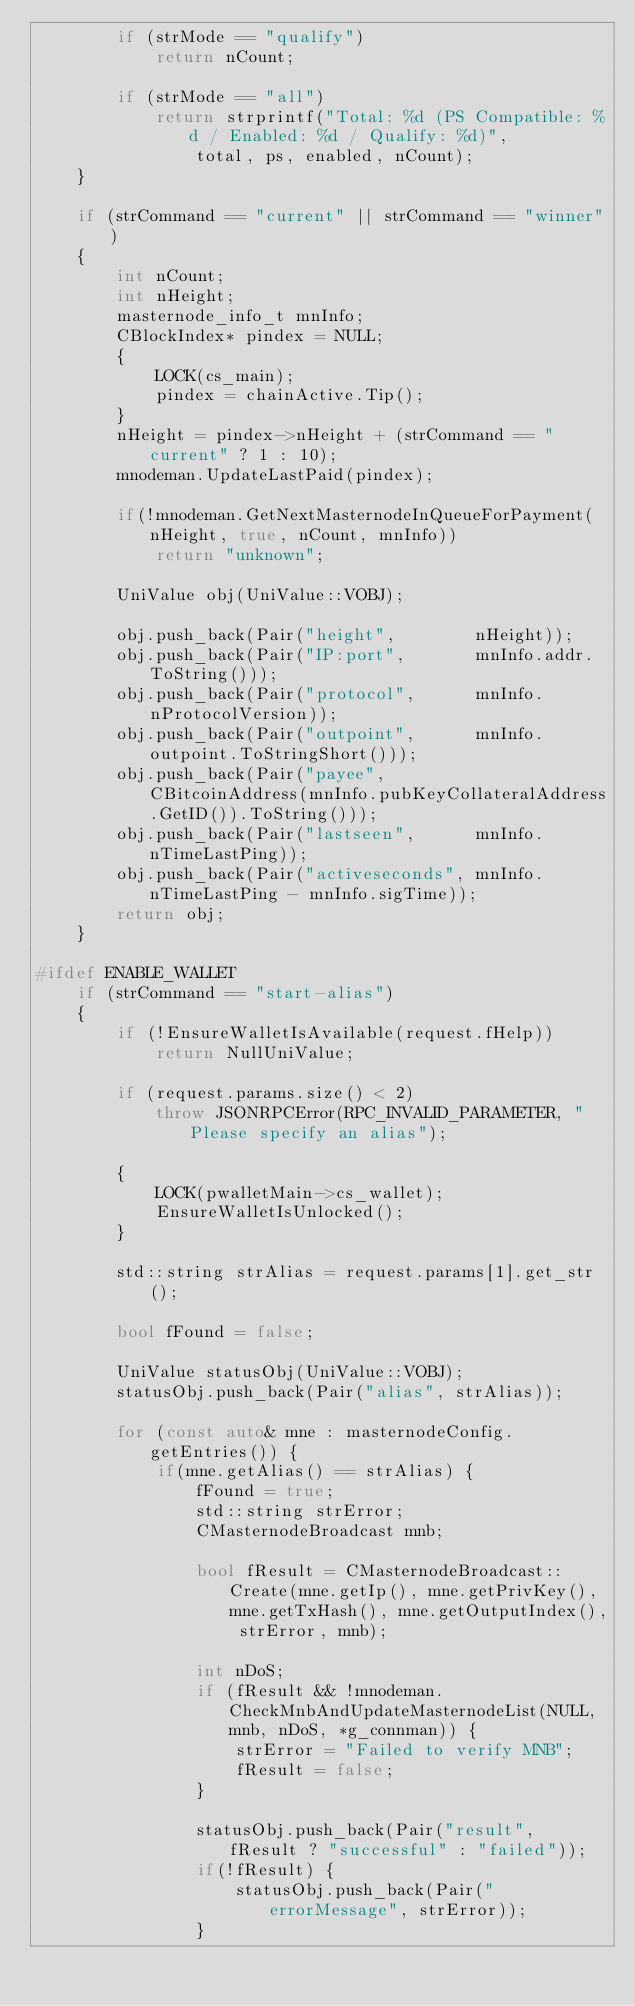<code> <loc_0><loc_0><loc_500><loc_500><_C++_>        if (strMode == "qualify")
            return nCount;

        if (strMode == "all")
            return strprintf("Total: %d (PS Compatible: %d / Enabled: %d / Qualify: %d)",
                total, ps, enabled, nCount);
    }

    if (strCommand == "current" || strCommand == "winner")
    {
        int nCount;
        int nHeight;
        masternode_info_t mnInfo;
        CBlockIndex* pindex = NULL;
        {
            LOCK(cs_main);
            pindex = chainActive.Tip();
        }
        nHeight = pindex->nHeight + (strCommand == "current" ? 1 : 10);
        mnodeman.UpdateLastPaid(pindex);

        if(!mnodeman.GetNextMasternodeInQueueForPayment(nHeight, true, nCount, mnInfo))
            return "unknown";

        UniValue obj(UniValue::VOBJ);

        obj.push_back(Pair("height",        nHeight));
        obj.push_back(Pair("IP:port",       mnInfo.addr.ToString()));
        obj.push_back(Pair("protocol",      mnInfo.nProtocolVersion));
        obj.push_back(Pair("outpoint",      mnInfo.outpoint.ToStringShort()));
        obj.push_back(Pair("payee",         CBitcoinAddress(mnInfo.pubKeyCollateralAddress.GetID()).ToString()));
        obj.push_back(Pair("lastseen",      mnInfo.nTimeLastPing));
        obj.push_back(Pair("activeseconds", mnInfo.nTimeLastPing - mnInfo.sigTime));
        return obj;
    }

#ifdef ENABLE_WALLET
    if (strCommand == "start-alias")
    {
        if (!EnsureWalletIsAvailable(request.fHelp))
            return NullUniValue;

        if (request.params.size() < 2)
            throw JSONRPCError(RPC_INVALID_PARAMETER, "Please specify an alias");

        {
            LOCK(pwalletMain->cs_wallet);
            EnsureWalletIsUnlocked();
        }

        std::string strAlias = request.params[1].get_str();

        bool fFound = false;

        UniValue statusObj(UniValue::VOBJ);
        statusObj.push_back(Pair("alias", strAlias));

        for (const auto& mne : masternodeConfig.getEntries()) {
            if(mne.getAlias() == strAlias) {
                fFound = true;
                std::string strError;
                CMasternodeBroadcast mnb;

                bool fResult = CMasternodeBroadcast::Create(mne.getIp(), mne.getPrivKey(), mne.getTxHash(), mne.getOutputIndex(), strError, mnb);

                int nDoS;
                if (fResult && !mnodeman.CheckMnbAndUpdateMasternodeList(NULL, mnb, nDoS, *g_connman)) {
                    strError = "Failed to verify MNB";
                    fResult = false;
                }

                statusObj.push_back(Pair("result", fResult ? "successful" : "failed"));
                if(!fResult) {
                    statusObj.push_back(Pair("errorMessage", strError));
                }</code> 